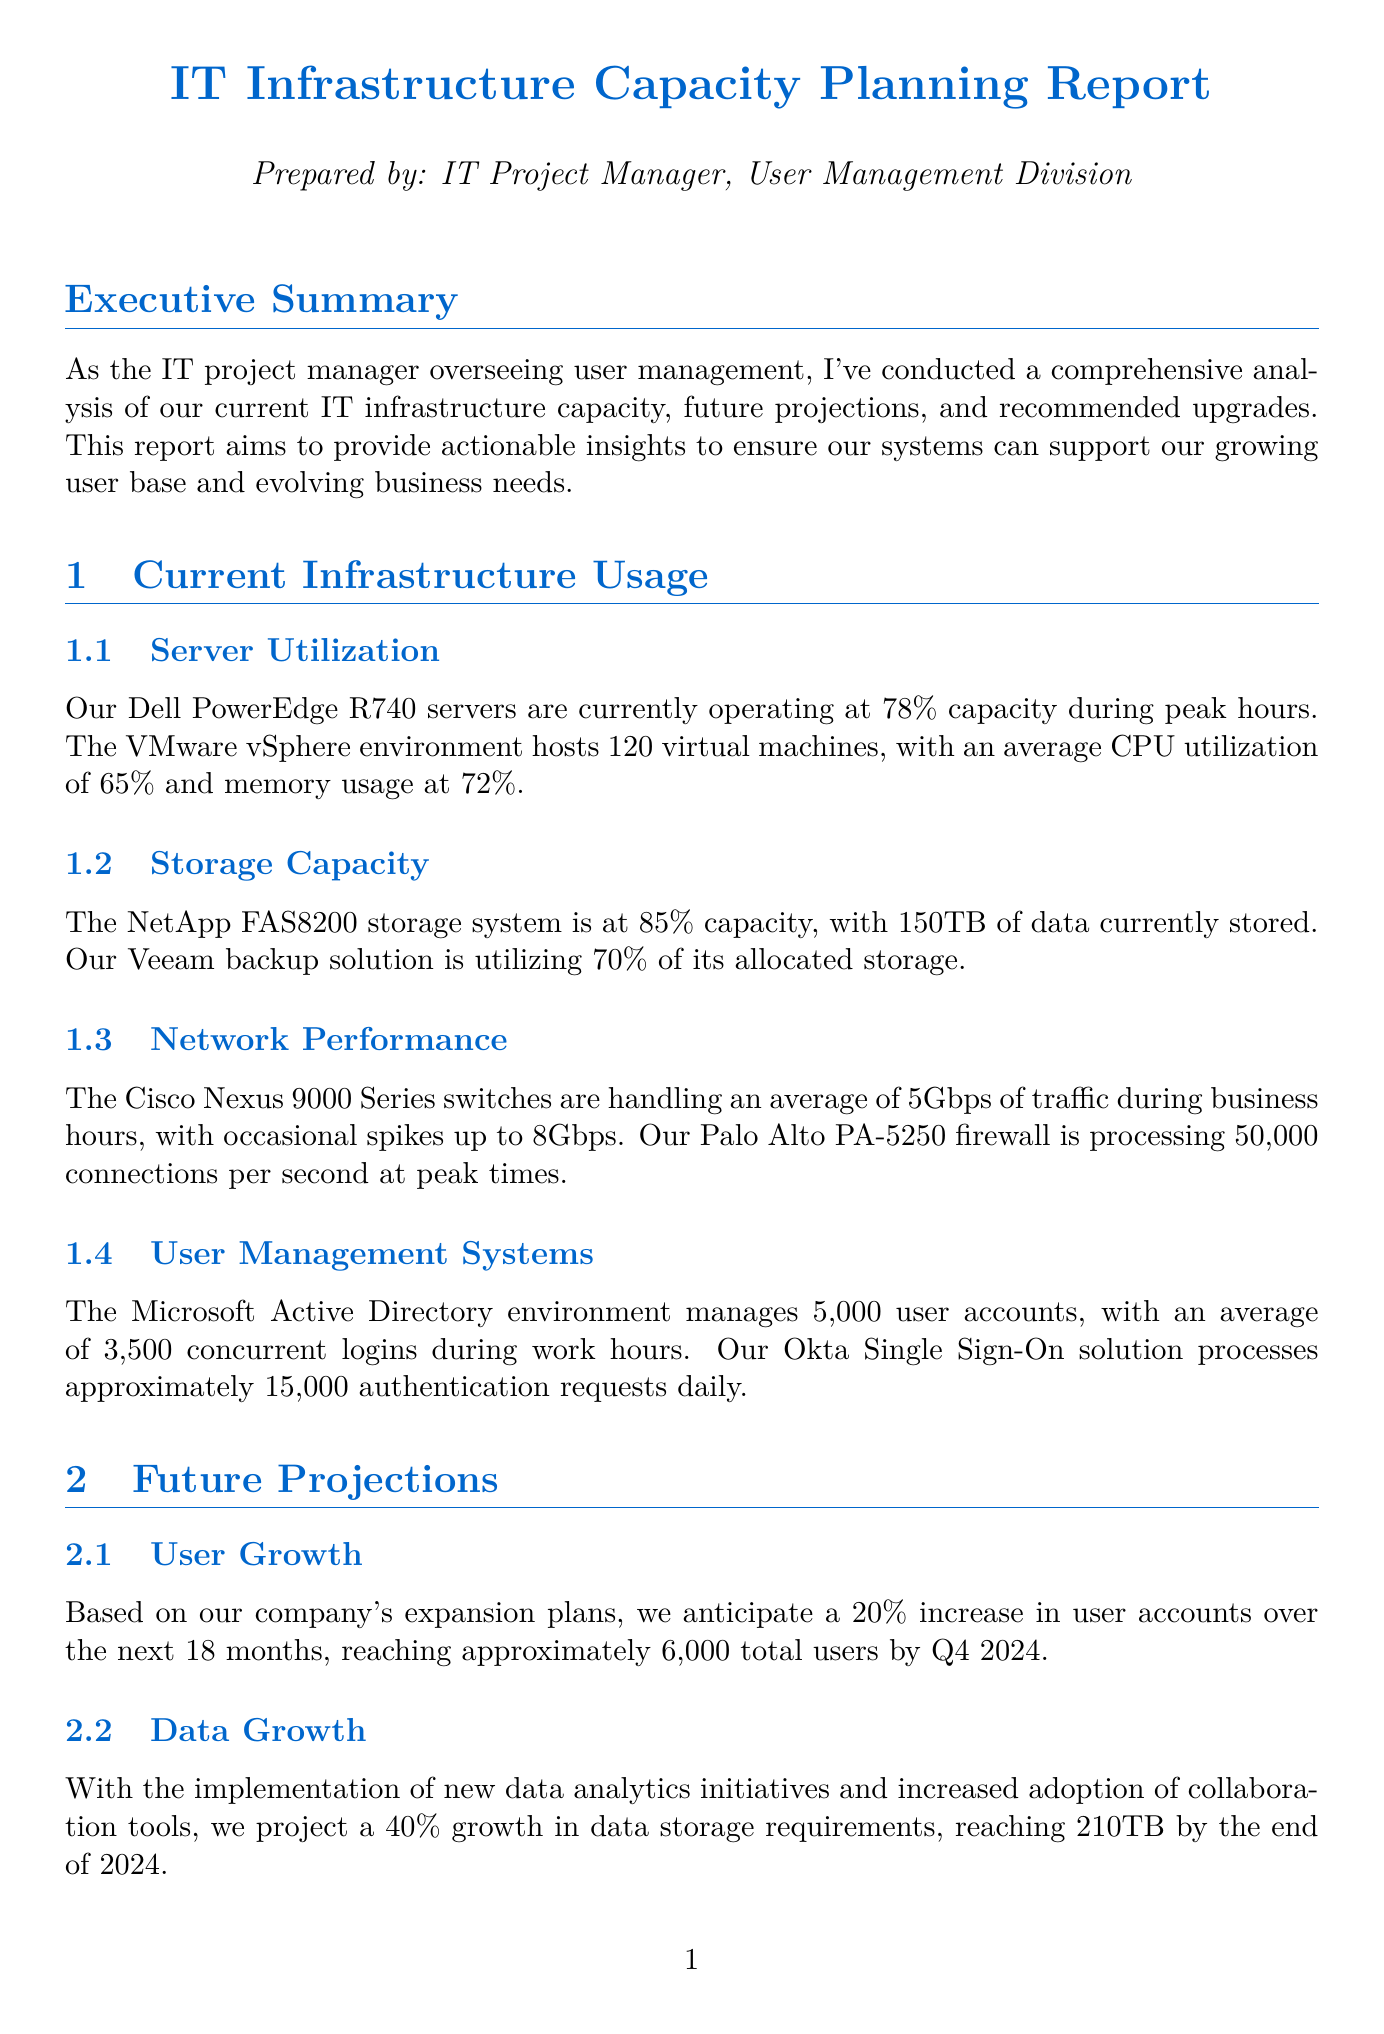What is the current server utilization percentage? The document states that the Dell PowerEdge R740 servers are operating at 78% capacity during peak hours.
Answer: 78% How many virtual machines are hosted in the VMware vSphere environment? It is mentioned that there are 120 virtual machines hosted in the VMware vSphere environment.
Answer: 120 What is the anticipated user growth percentage over the next 18 months? The report projects a 20% increase in user accounts over the next 18 months.
Answer: 20% What new storage system is recommended for implementation? The document recommends implementing a NetApp AFF A400 all-flash array for additional storage.
Answer: NetApp AFF A400 How much additional storage capacity is proposed to address performance needs? The report suggests providing an additional 200TB of high-performance storage.
Answer: 200TB What is the total estimated cost for the proposed upgrades? The estimated total cost for the upgrades is $1.5 million.
Answer: $1.5 million In which quarter is the storage expansion phase set to begin? The implementation timeline indicates that the storage expansion is recommended to start in Q3 2023.
Answer: Q3 2023 What percentage increase in network traffic is expected within the next 12 months? The expected increase in network traffic is projected to be 25% within the next 12 months.
Answer: 25% What is the average number of concurrent logins during work hours? The document states there is an average of 3,500 concurrent logins during work hours.
Answer: 3,500 